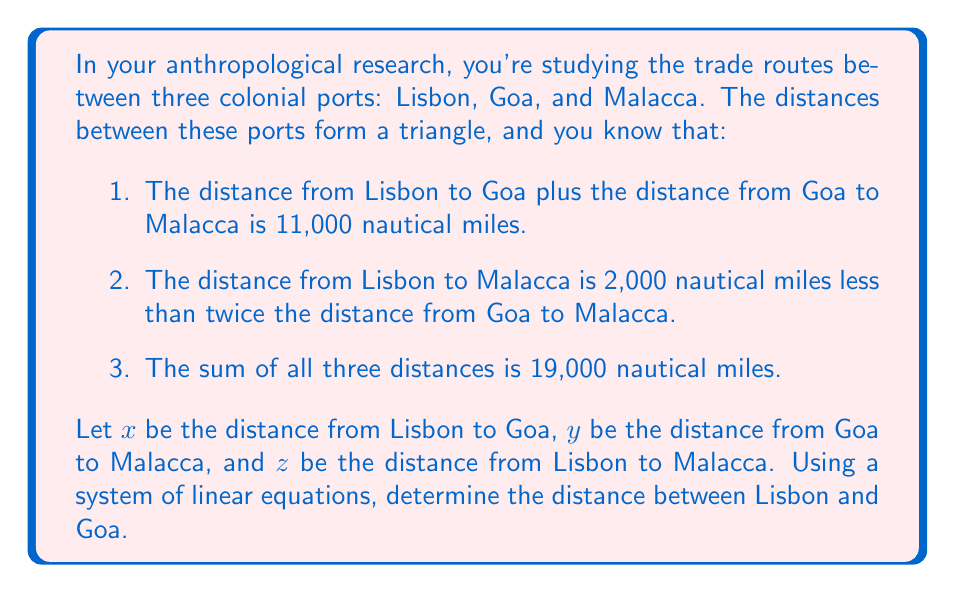Solve this math problem. Let's approach this step-by-step using the given information:

1) First, let's set up our system of equations based on the given information:

   Equation 1: $x + y = 11000$ (Lisbon to Goa plus Goa to Malacca)
   Equation 2: $z = 2y - 2000$ (Lisbon to Malacca relation)
   Equation 3: $x + y + z = 19000$ (Sum of all distances)

2) We can substitute the expression for $z$ from Equation 2 into Equation 3:

   $x + y + (2y - 2000) = 19000$

3) Simplify:

   $x + 3y = 21000$

4) Now we have two equations with two unknowns:

   Equation 1: $x + y = 11000$
   Equation 4: $x + 3y = 21000$

5) We can solve this system by subtracting Equation 1 from Equation 4:

   $(x + 3y) - (x + y) = 21000 - 11000$
   $2y = 10000$

6) Solve for $y$:

   $y = 5000$

7) Now substitute this value of $y$ back into Equation 1:

   $x + 5000 = 11000$
   $x = 6000$

Therefore, the distance between Lisbon and Goa is 6,000 nautical miles.
Answer: 6,000 nautical miles 